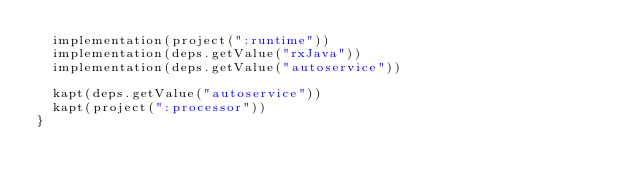Convert code to text. <code><loc_0><loc_0><loc_500><loc_500><_Kotlin_>  implementation(project(":runtime"))
  implementation(deps.getValue("rxJava"))
  implementation(deps.getValue("autoservice"))

  kapt(deps.getValue("autoservice"))
  kapt(project(":processor"))
}
</code> 